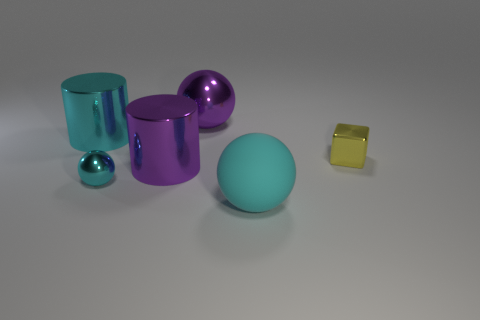What is the big object that is to the left of the large cyan sphere and in front of the cyan metal cylinder made of? The large object to the left of the cyan sphere and in front of the cyan metal cylinder appears to have a reflective surface suggestive of a metallic material, which is consistent across the objects in the image, indicating that this object is also likely made of metal. 